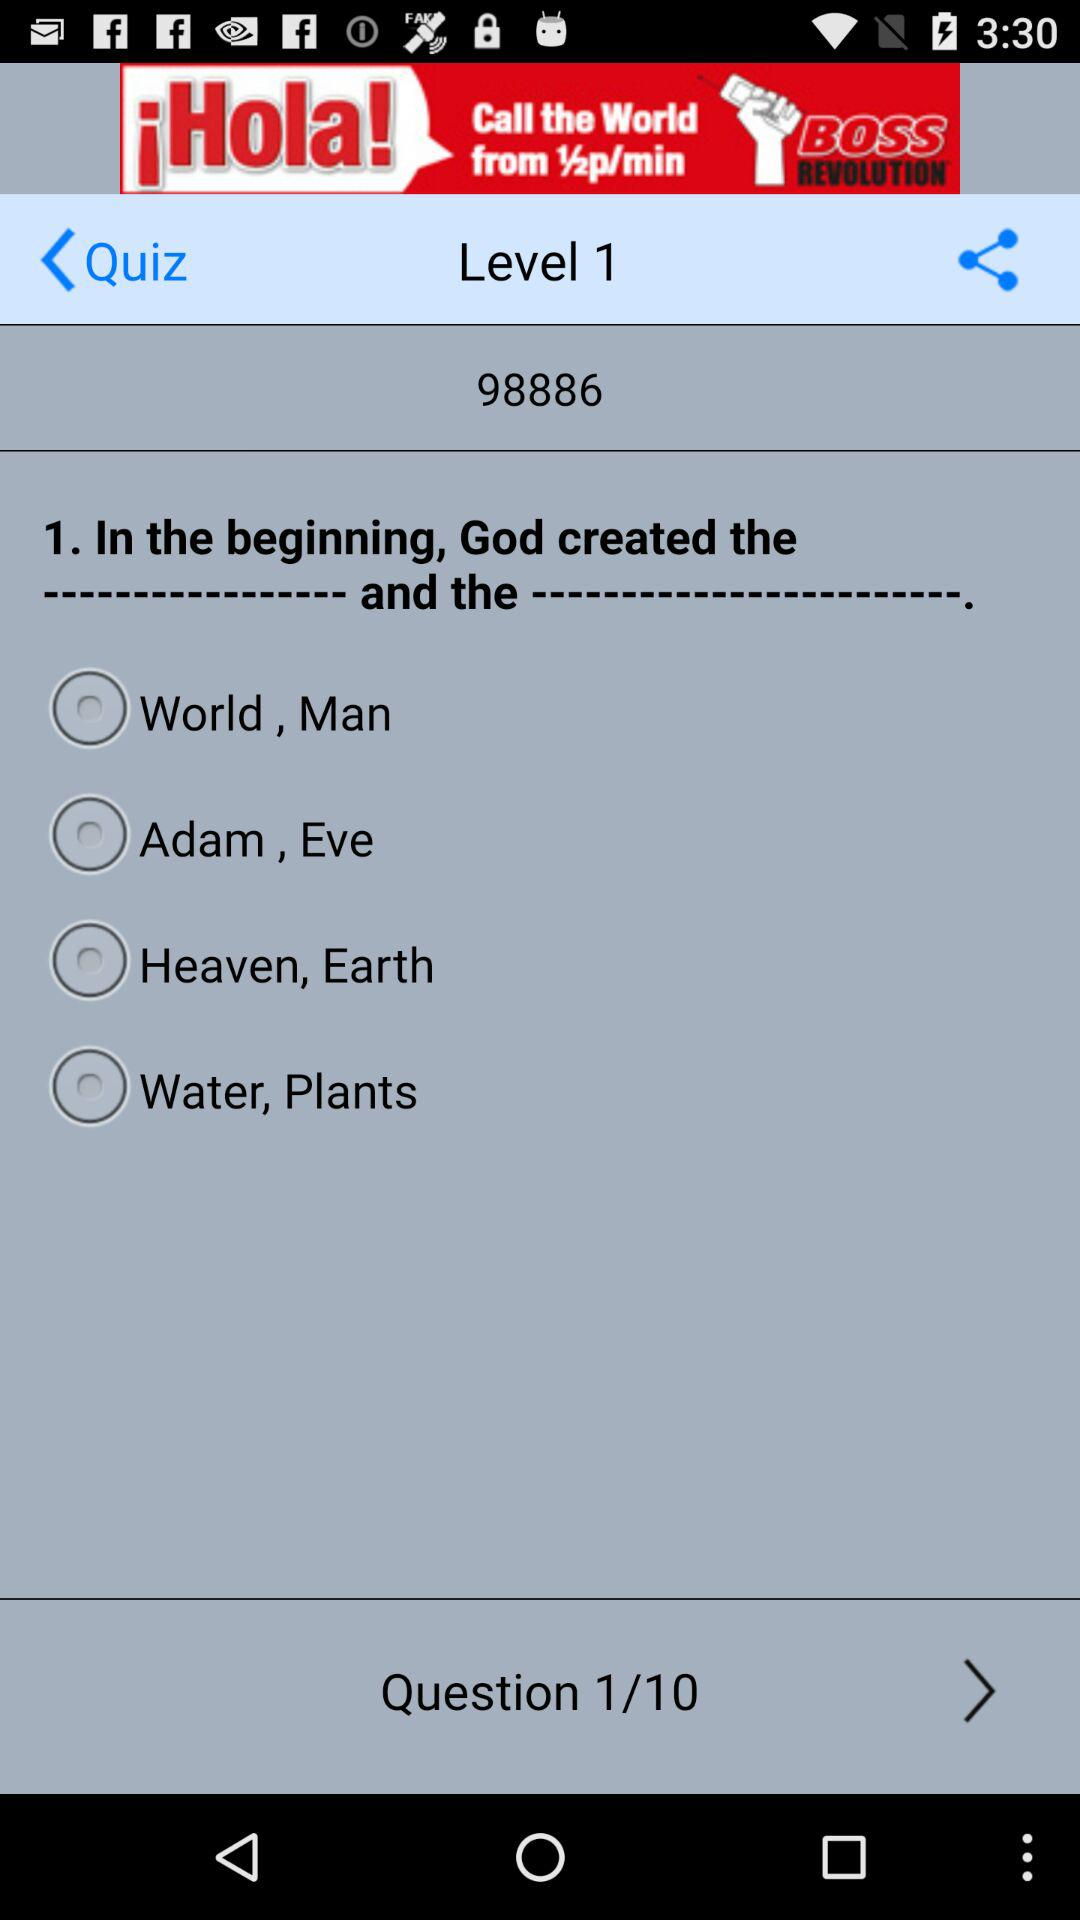How many levels are there in this quiz?
Answer the question using a single word or phrase. 1 